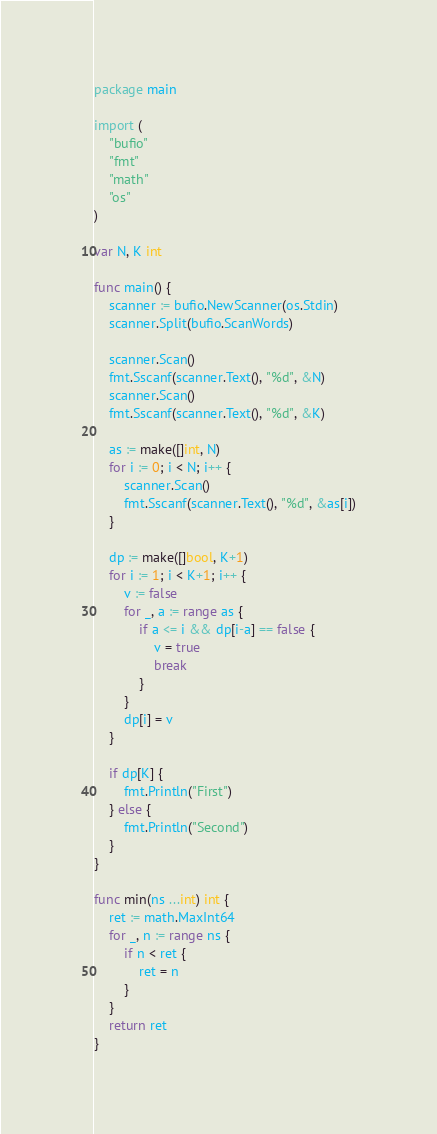<code> <loc_0><loc_0><loc_500><loc_500><_Go_>package main

import (
	"bufio"
	"fmt"
	"math"
	"os"
)

var N, K int

func main() {
	scanner := bufio.NewScanner(os.Stdin)
	scanner.Split(bufio.ScanWords)

	scanner.Scan()
	fmt.Sscanf(scanner.Text(), "%d", &N)
	scanner.Scan()
	fmt.Sscanf(scanner.Text(), "%d", &K)

	as := make([]int, N)
	for i := 0; i < N; i++ {
		scanner.Scan()
		fmt.Sscanf(scanner.Text(), "%d", &as[i])
	}

	dp := make([]bool, K+1)
	for i := 1; i < K+1; i++ {
		v := false
		for _, a := range as {
			if a <= i && dp[i-a] == false {
				v = true
				break
			}
		}
		dp[i] = v
	}

	if dp[K] {
		fmt.Println("First")
	} else {
		fmt.Println("Second")
	}
}

func min(ns ...int) int {
	ret := math.MaxInt64
	for _, n := range ns {
		if n < ret {
			ret = n
		}
	}
	return ret
}
</code> 